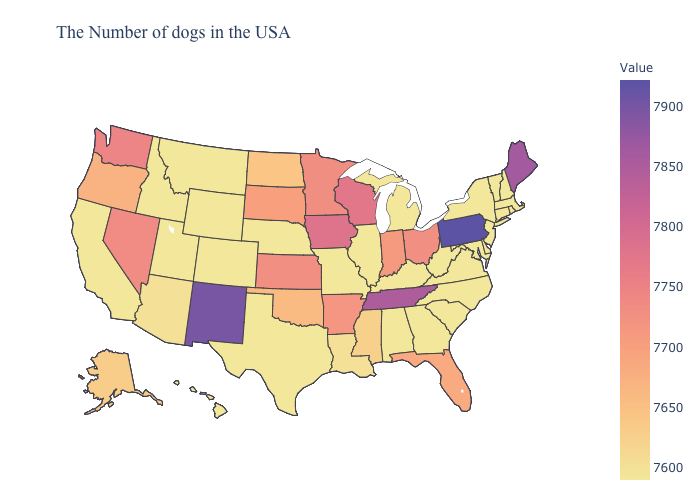Among the states that border Wyoming , does Utah have the highest value?
Short answer required. No. Does Michigan have the lowest value in the USA?
Short answer required. Yes. Does Minnesota have the lowest value in the MidWest?
Short answer required. No. Is the legend a continuous bar?
Give a very brief answer. Yes. Does California have the lowest value in the USA?
Keep it brief. Yes. Among the states that border Massachusetts , which have the highest value?
Give a very brief answer. Rhode Island, New Hampshire, Vermont, Connecticut, New York. Among the states that border Delaware , which have the lowest value?
Give a very brief answer. New Jersey, Maryland. 